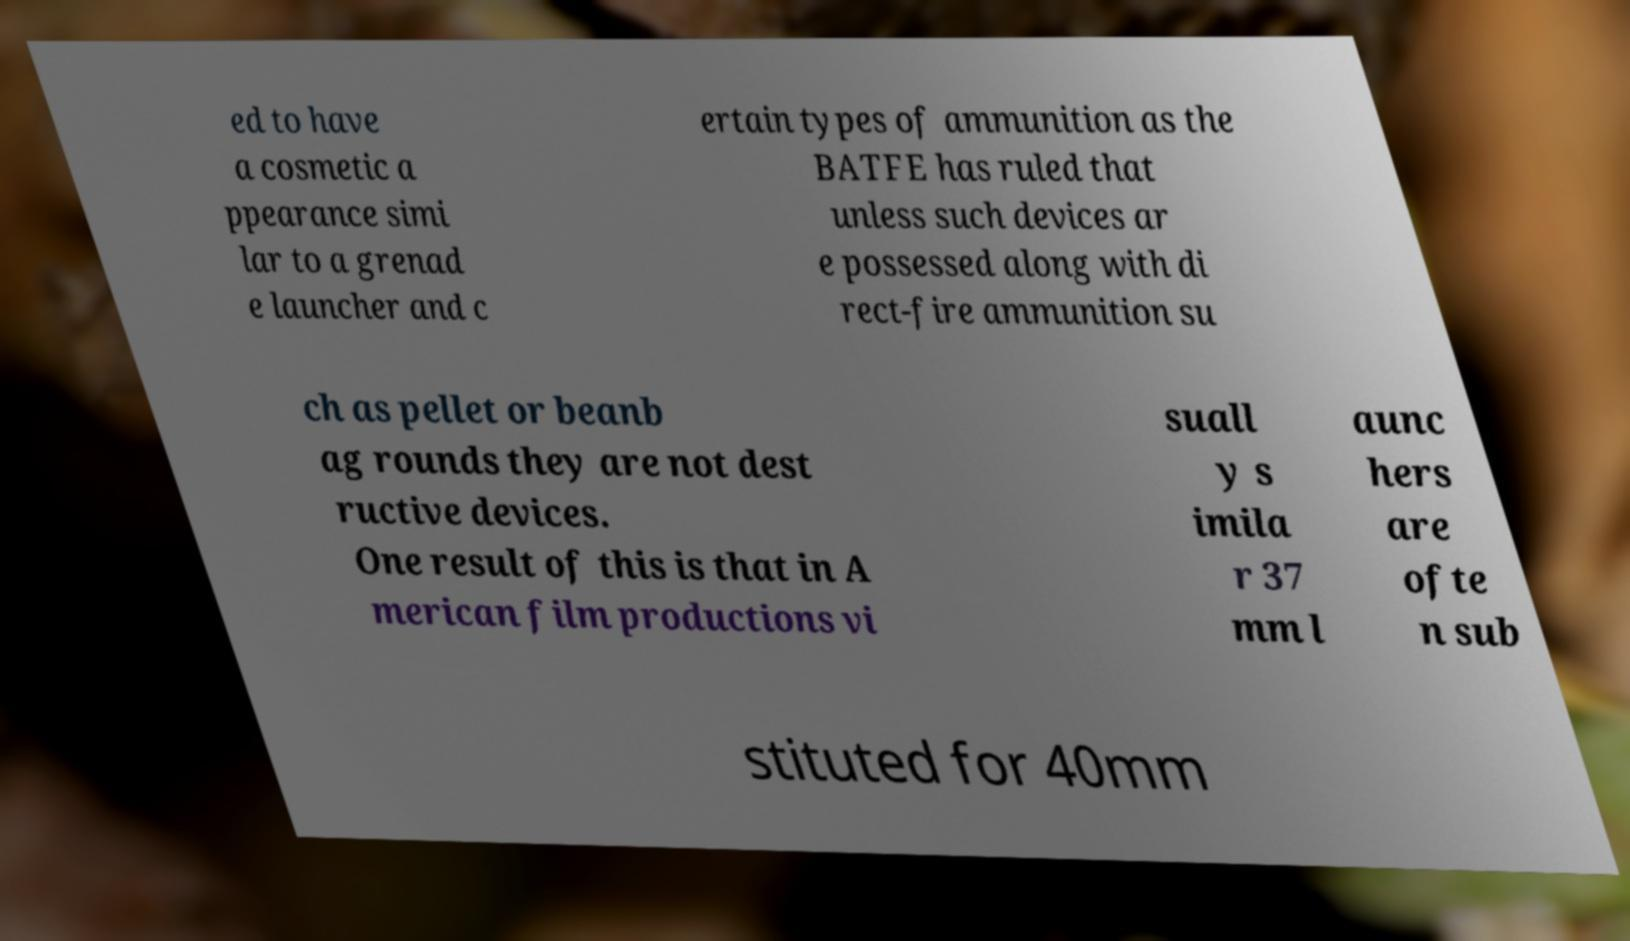What messages or text are displayed in this image? I need them in a readable, typed format. ed to have a cosmetic a ppearance simi lar to a grenad e launcher and c ertain types of ammunition as the BATFE has ruled that unless such devices ar e possessed along with di rect-fire ammunition su ch as pellet or beanb ag rounds they are not dest ructive devices. One result of this is that in A merican film productions vi suall y s imila r 37 mm l aunc hers are ofte n sub stituted for 40mm 